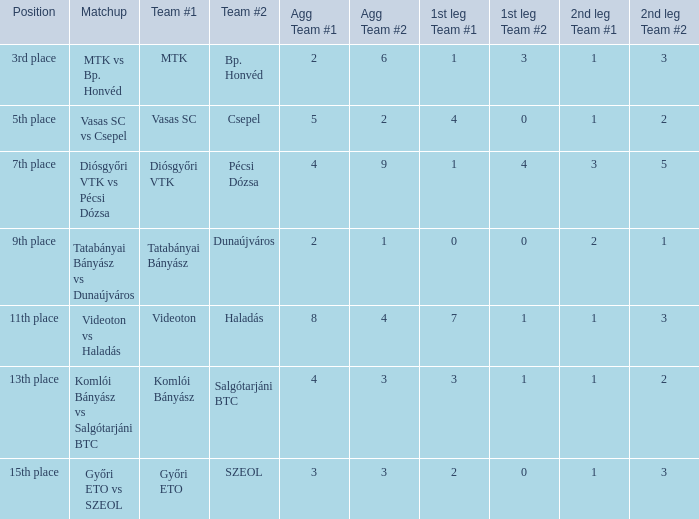What position has a 2-6 agg.? 3rd place. 